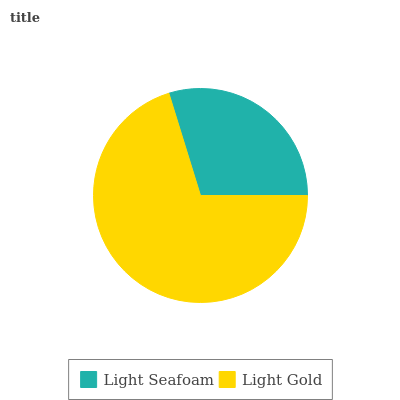Is Light Seafoam the minimum?
Answer yes or no. Yes. Is Light Gold the maximum?
Answer yes or no. Yes. Is Light Gold the minimum?
Answer yes or no. No. Is Light Gold greater than Light Seafoam?
Answer yes or no. Yes. Is Light Seafoam less than Light Gold?
Answer yes or no. Yes. Is Light Seafoam greater than Light Gold?
Answer yes or no. No. Is Light Gold less than Light Seafoam?
Answer yes or no. No. Is Light Gold the high median?
Answer yes or no. Yes. Is Light Seafoam the low median?
Answer yes or no. Yes. Is Light Seafoam the high median?
Answer yes or no. No. Is Light Gold the low median?
Answer yes or no. No. 